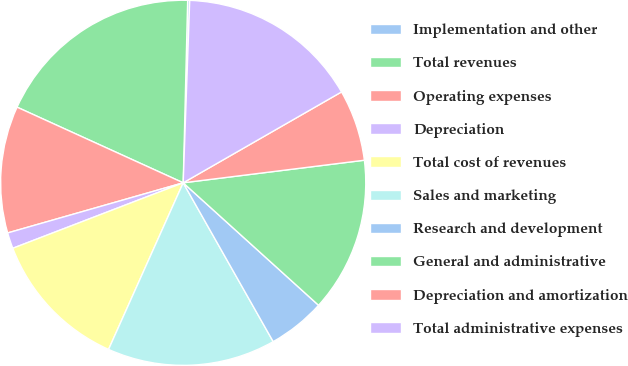<chart> <loc_0><loc_0><loc_500><loc_500><pie_chart><fcel>Implementation and other<fcel>Total revenues<fcel>Operating expenses<fcel>Depreciation<fcel>Total cost of revenues<fcel>Sales and marketing<fcel>Research and development<fcel>General and administrative<fcel>Depreciation and amortization<fcel>Total administrative expenses<nl><fcel>0.18%<fcel>18.59%<fcel>11.23%<fcel>1.41%<fcel>12.46%<fcel>14.91%<fcel>5.09%<fcel>13.68%<fcel>6.32%<fcel>16.14%<nl></chart> 